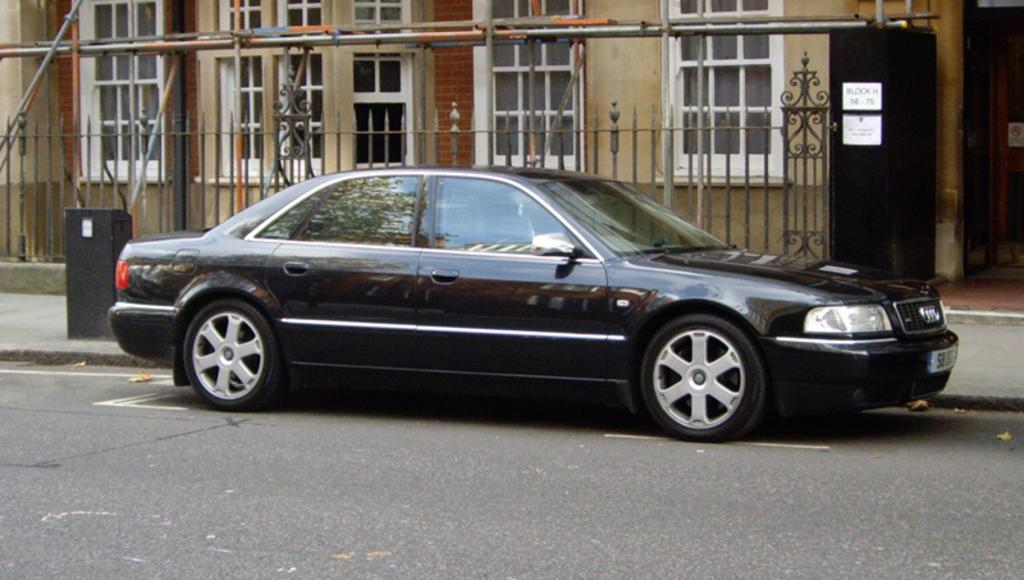What type of motor vehicle can be seen on the road in the image? There is a motor vehicle on the road in the image, but the specific type is not mentioned. What can be found near the motor vehicle in the image? There are grills visible in the image. What structure is present in the image? There is a building in the image. What is attached to the door in the image? There is a paper pasted on a door in the image. What type of container is present in the image? There is a bin in the image. What type of zinc is used to make the bin in the image? There is no mention of zinc being used to make the bin in the image. How are the grills sorted in the image? The image does not show any sorting of grills; it only shows their presence. 